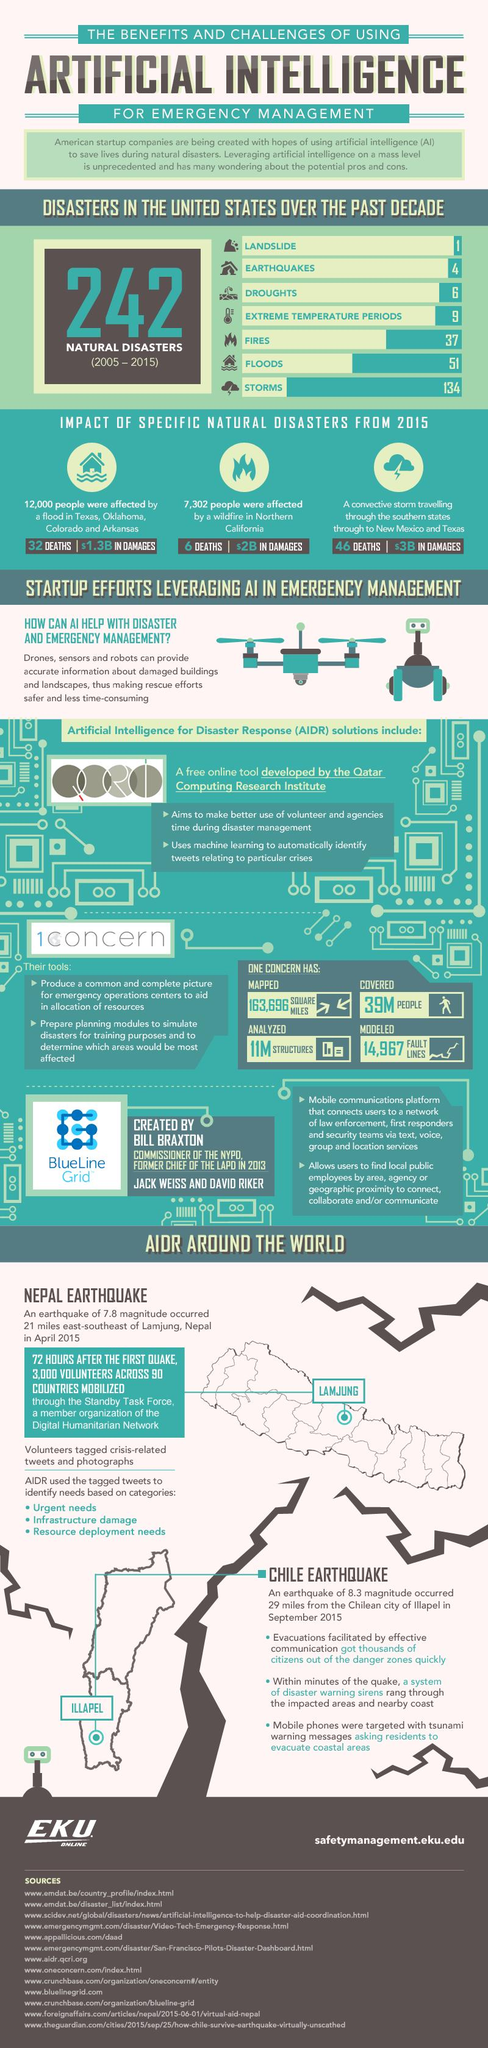Mention a couple of crucial points in this snapshot. The number of deaths caused by wildfires is 6. The record of natural disasters has been shown over the past [X] years/decade. Of the natural disasters, floods and fires were the most prevalent, with a total count of 88. The three natural disasters that were ranked as the bottom three in terms of frequency were landslides, earthquakes, and droughts. The total damage value due to floods in Texas, Oklahoma, Colorado, and Arkansas is estimated to be $1.3 billion. 